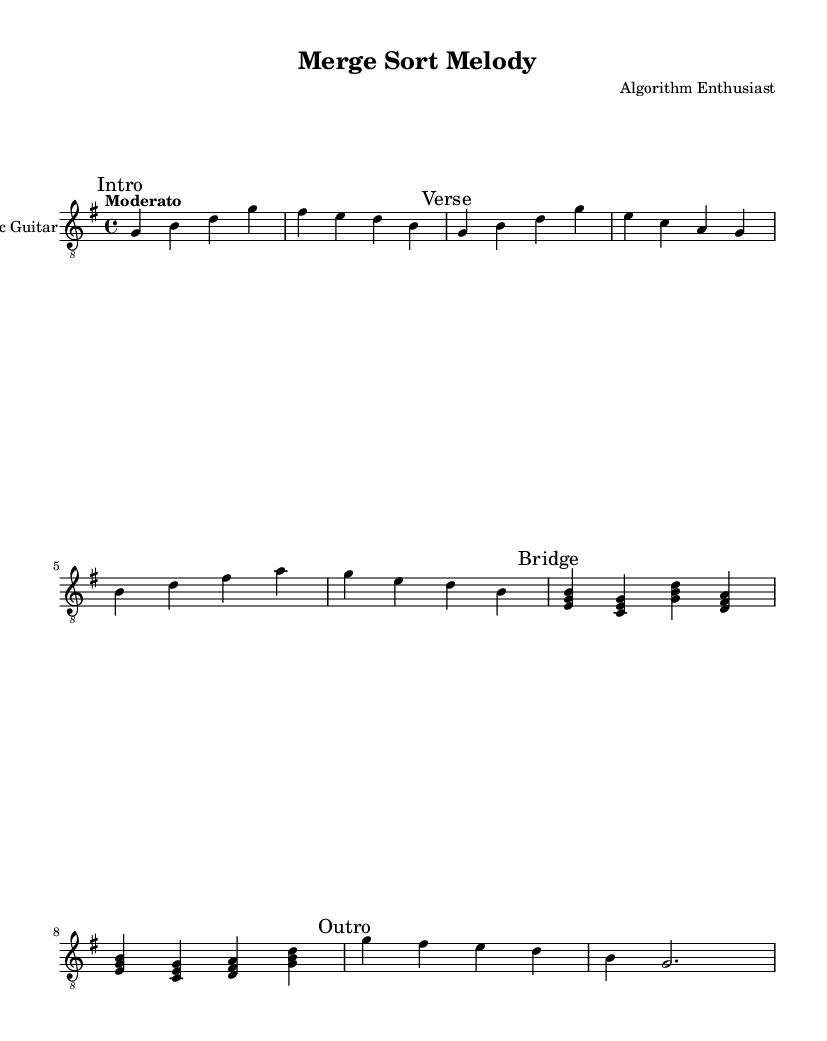What is the key signature of this music? The key signature is G major, which contains one sharp (F sharp).
Answer: G major What is the time signature of this piece? The time signature is 4/4, indicating four beats per measure.
Answer: 4/4 What is the tempo marking for this composition? The tempo marking is "Moderato," which suggests a moderate speed for the piece.
Answer: Moderato How many sections are present in the piece? There are four sections: Intro, Verse, Bridge, and Outro.
Answer: Four What is the final note of the Outro section? The final note is G, which is sustained as a half-note in the last measure.
Answer: G Which two notes appear in the Bridge section that are not present in the Intro? The notes C and F appear in the Bridge but not in the Intro.
Answer: C and F What instrument is specified for this score? The instrument specified is "Acoustic Guitar," particularly a nylon-string guitar.
Answer: Acoustic Guitar 